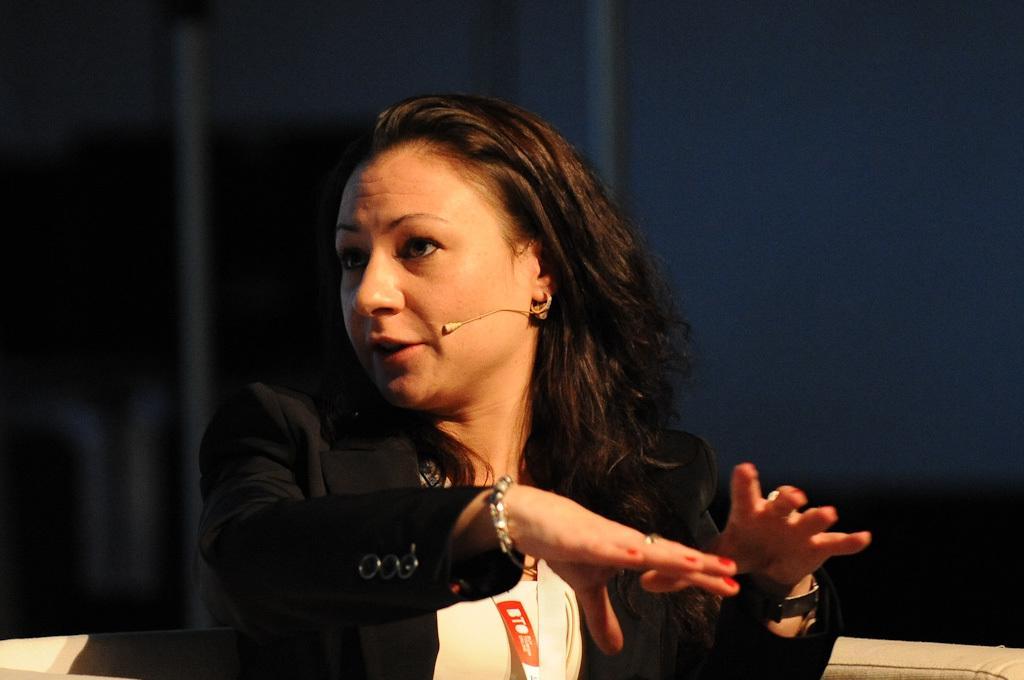How would you summarize this image in a sentence or two? In this image we can see a woman wearing a coat and a microphone is sitting on a sofa. In the background, we can see the curtains. 